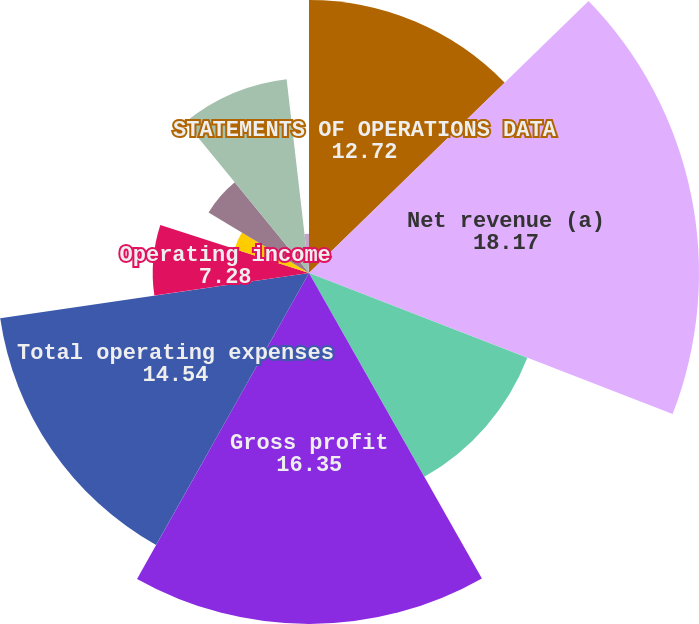<chart> <loc_0><loc_0><loc_500><loc_500><pie_chart><fcel>STATEMENTS OF OPERATIONS DATA<fcel>Net revenue (a)<fcel>Cost of revenue<fcel>Gross profit<fcel>Total operating expenses<fcel>Operating income<fcel>Interest and other income<fcel>Income before provision for<fcel>Net income<fcel>Basic<nl><fcel>12.72%<fcel>18.17%<fcel>10.91%<fcel>16.35%<fcel>14.54%<fcel>7.28%<fcel>3.65%<fcel>5.46%<fcel>9.09%<fcel>1.83%<nl></chart> 